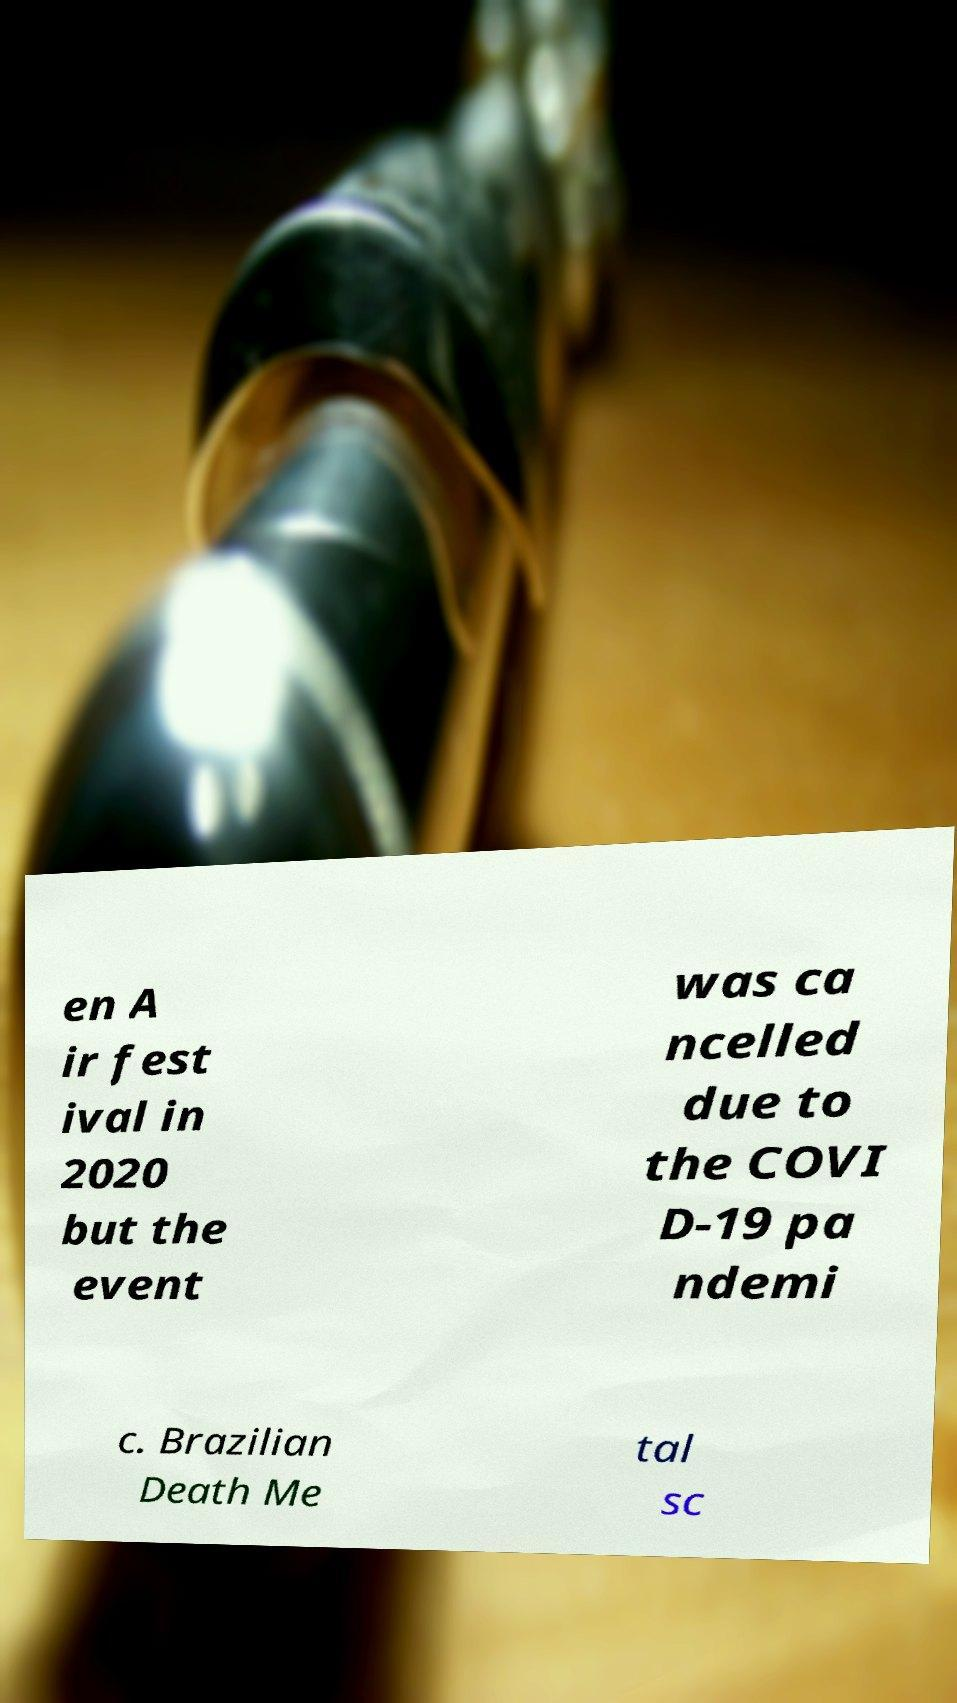There's text embedded in this image that I need extracted. Can you transcribe it verbatim? en A ir fest ival in 2020 but the event was ca ncelled due to the COVI D-19 pa ndemi c. Brazilian Death Me tal sc 